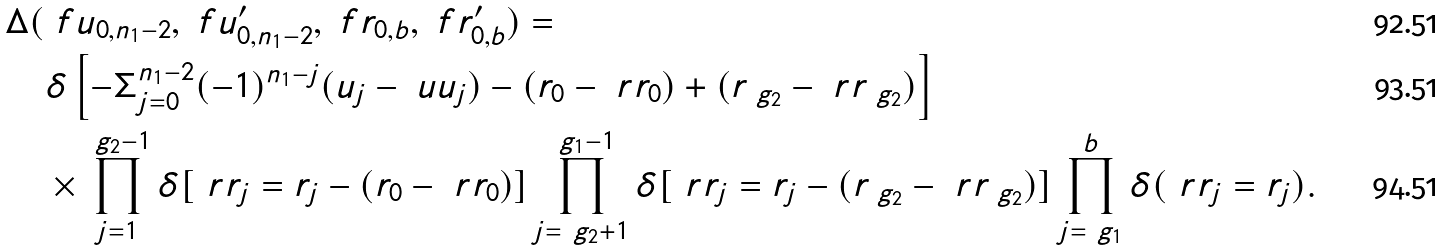<formula> <loc_0><loc_0><loc_500><loc_500>\Delta ( & \ f u _ { 0 , n _ { 1 } - 2 } , \ f u ^ { \prime } _ { 0 , n _ { 1 } - 2 } , \ f r _ { 0 , b } , \ f r ^ { \prime } _ { 0 , b } ) = \\ & \delta \left [ - \Sigma _ { j = 0 } ^ { n _ { 1 } - 2 } ( - 1 ) ^ { n _ { 1 } - j } ( u _ { j } - \ u u _ { j } ) - ( r _ { 0 } - \ r r _ { 0 } ) + ( r _ { \ g _ { 2 } } - \ r r _ { \ g _ { 2 } } ) \right ] \\ & \times \prod _ { j = 1 } ^ { \ g _ { 2 } - 1 } \delta [ \ r r _ { j } = r _ { j } - ( r _ { 0 } - \ r r _ { 0 } ) ] \prod _ { j = \ g _ { 2 } + 1 } ^ { \ g _ { 1 } - 1 } \delta [ \ r r _ { j } = r _ { j } - ( r _ { \ g _ { 2 } } - \ r r _ { \ g _ { 2 } } ) ] \prod _ { j = \ g _ { 1 } } ^ { b } \delta ( \ r r _ { j } = r _ { j } ) .</formula> 